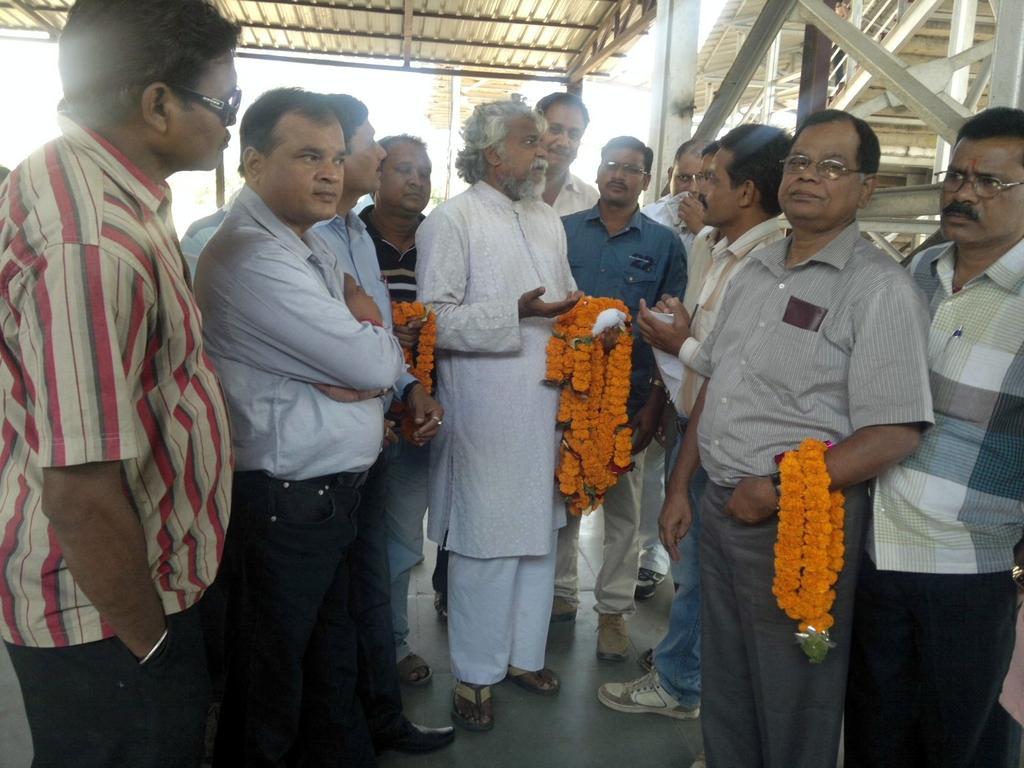How would you summarize this image in a sentence or two? This picture might be taken inside the room. In this image, on the right side, we can see a man standing and holding a garland in his hand. In the middle of the image, we can see a man standing and holding a garland in his hand, we can also see a group of people in the room. At the top, we can see a roof and few metal pillars. 